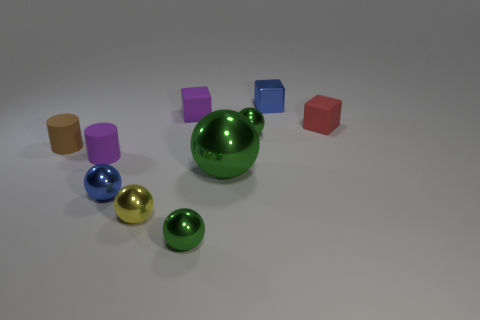Subtract all blue blocks. How many blocks are left? 2 Subtract all tiny balls. How many balls are left? 1 Subtract all green spheres. How many were subtracted if there are1green spheres left? 2 Subtract 4 spheres. How many spheres are left? 1 Subtract all gray cylinders. Subtract all yellow cubes. How many cylinders are left? 2 Subtract all gray cubes. How many red cylinders are left? 0 Subtract all tiny green balls. Subtract all purple cylinders. How many objects are left? 7 Add 9 tiny yellow balls. How many tiny yellow balls are left? 10 Add 1 small brown cylinders. How many small brown cylinders exist? 2 Subtract 0 brown cubes. How many objects are left? 10 